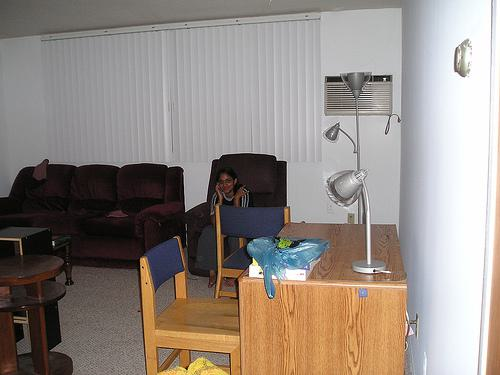What kind of styles do the furnishings in this room suggest? Based on the visible furnishings, such as the couch, chairs, and lamp, the room suggests a practical and casual living space, likely designed for comfort without following any specific high-end design theme. 